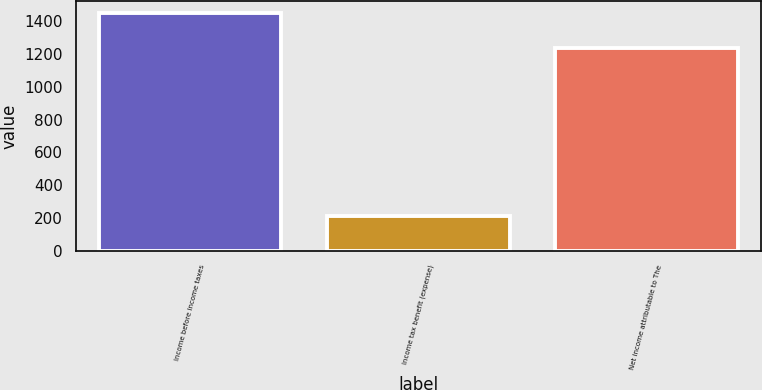Convert chart. <chart><loc_0><loc_0><loc_500><loc_500><bar_chart><fcel>Income before income taxes<fcel>Income tax benefit (expense)<fcel>Net income attributable to The<nl><fcel>1448<fcel>214<fcel>1234<nl></chart> 